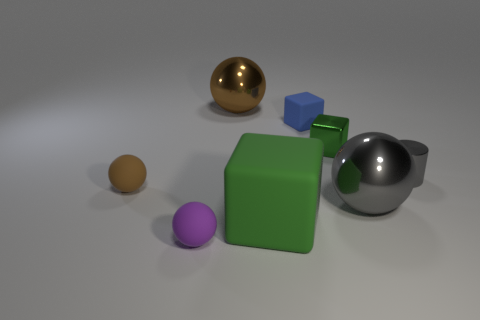What material is the large block that is the same color as the tiny metallic cube?
Your answer should be compact. Rubber. Does the small thing that is behind the small green metallic object have the same material as the big gray ball?
Your answer should be very brief. No. There is a tiny matte object on the right side of the purple rubber sphere; what is its shape?
Give a very brief answer. Cube. What material is the brown ball that is the same size as the blue rubber block?
Your answer should be compact. Rubber. What number of objects are either cubes that are left of the green shiny block or rubber spheres that are left of the tiny purple sphere?
Provide a short and direct response. 3. What size is the purple object that is the same material as the tiny brown sphere?
Your answer should be very brief. Small. How many metallic objects are large gray things or tiny purple objects?
Provide a short and direct response. 1. The purple rubber sphere has what size?
Your answer should be compact. Small. Is the size of the blue matte thing the same as the gray metal ball?
Your answer should be very brief. No. There is a large thing behind the small brown object; what is its material?
Offer a terse response. Metal. 